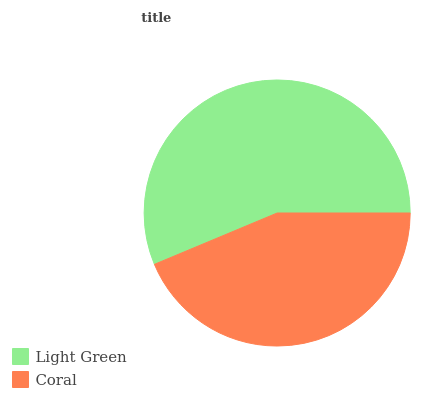Is Coral the minimum?
Answer yes or no. Yes. Is Light Green the maximum?
Answer yes or no. Yes. Is Coral the maximum?
Answer yes or no. No. Is Light Green greater than Coral?
Answer yes or no. Yes. Is Coral less than Light Green?
Answer yes or no. Yes. Is Coral greater than Light Green?
Answer yes or no. No. Is Light Green less than Coral?
Answer yes or no. No. Is Light Green the high median?
Answer yes or no. Yes. Is Coral the low median?
Answer yes or no. Yes. Is Coral the high median?
Answer yes or no. No. Is Light Green the low median?
Answer yes or no. No. 